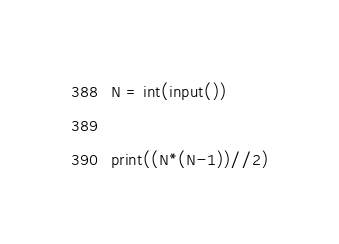Convert code to text. <code><loc_0><loc_0><loc_500><loc_500><_Python_>N = int(input())

print((N*(N-1))//2)</code> 